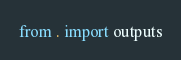<code> <loc_0><loc_0><loc_500><loc_500><_Python_>from . import outputs
</code> 